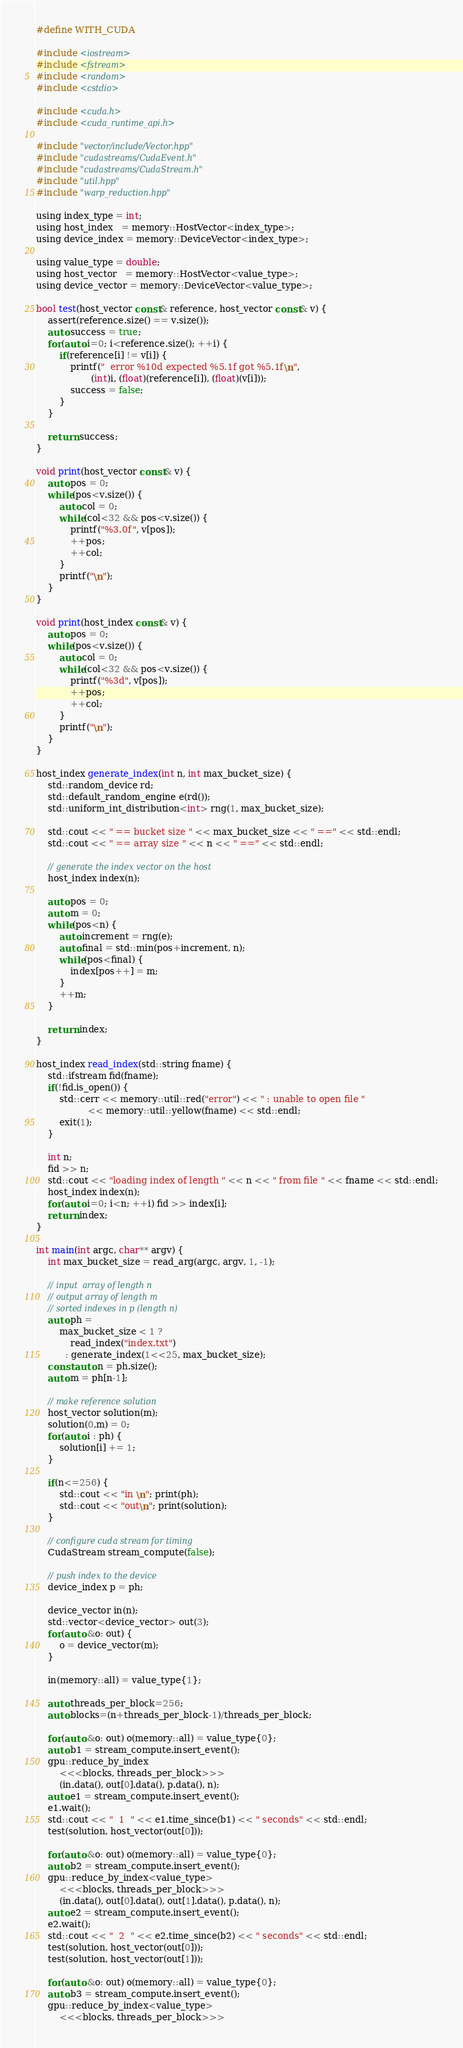<code> <loc_0><loc_0><loc_500><loc_500><_Cuda_>#define WITH_CUDA

#include <iostream>
#include <fstream>
#include <random>
#include <cstdio>

#include <cuda.h>
#include <cuda_runtime_api.h>

#include "vector/include/Vector.hpp"
#include "cudastreams/CudaEvent.h"
#include "cudastreams/CudaStream.h"
#include "util.hpp"
#include "warp_reduction.hpp"

using index_type = int;
using host_index   = memory::HostVector<index_type>;
using device_index = memory::DeviceVector<index_type>;

using value_type = double;
using host_vector   = memory::HostVector<value_type>;
using device_vector = memory::DeviceVector<value_type>;

bool test(host_vector const& reference, host_vector const& v) {
    assert(reference.size() == v.size());
    auto success = true;
    for(auto i=0; i<reference.size(); ++i) {
        if(reference[i] != v[i]) {
            printf("  error %10d expected %5.1f got %5.1f\n",
                   (int)i, (float)(reference[i]), (float)(v[i]));
            success = false;
        }
    }

    return success;
}

void print(host_vector const& v) {
    auto pos = 0;
    while(pos<v.size()) {
        auto col = 0;
        while(col<32 && pos<v.size()) {
            printf("%3.0f", v[pos]);
            ++pos;
            ++col;
        }
        printf("\n");
    }
}

void print(host_index const& v) {
    auto pos = 0;
    while(pos<v.size()) {
        auto col = 0;
        while(col<32 && pos<v.size()) {
            printf("%3d", v[pos]);
            ++pos;
            ++col;
        }
        printf("\n");
    }
}

host_index generate_index(int n, int max_bucket_size) {
    std::random_device rd;
    std::default_random_engine e(rd());
    std::uniform_int_distribution<int> rng(1, max_bucket_size);

    std::cout << " == bucket size " << max_bucket_size << " ==" << std::endl;
    std::cout << " == array size " << n << " ==" << std::endl;

    // generate the index vector on the host
    host_index index(n);

    auto pos = 0;
    auto m = 0;
    while(pos<n) {
        auto increment = rng(e);
        auto final = std::min(pos+increment, n);
        while(pos<final) {
            index[pos++] = m;
        }
        ++m;
    }

    return index;
}

host_index read_index(std::string fname) {
    std::ifstream fid(fname);
    if(!fid.is_open()) {
        std::cerr << memory::util::red("error") << " : unable to open file "
                  << memory::util::yellow(fname) << std::endl;
        exit(1);
    }

    int n;
    fid >> n;
    std::cout << "loading index of length " << n << " from file " << fname << std::endl;
    host_index index(n);
    for(auto i=0; i<n; ++i) fid >> index[i];
    return index;
}

int main(int argc, char** argv) {
    int max_bucket_size = read_arg(argc, argv, 1, -1);

    // input  array of length n
    // output array of length m
    // sorted indexes in p (length n)
    auto ph =
        max_bucket_size < 1 ?
            read_index("index.txt")
          : generate_index(1<<25, max_bucket_size);
    const auto n = ph.size();
    auto m = ph[n-1];

    // make reference solution
    host_vector solution(m);
    solution(0,m) = 0;
    for(auto i : ph) {
        solution[i] += 1;
    }

    if(n<=256) {
        std::cout << "in \n"; print(ph);
        std::cout << "out\n"; print(solution);
    }

    // configure cuda stream for timing
    CudaStream stream_compute(false);

    // push index to the device
    device_index p = ph;

    device_vector in(n);
    std::vector<device_vector> out(3);
    for(auto &o: out) {
        o = device_vector(m);
    }

    in(memory::all) = value_type{1};

    auto threads_per_block=256;
    auto blocks=(n+threads_per_block-1)/threads_per_block;

    for(auto &o: out) o(memory::all) = value_type{0};
    auto b1 = stream_compute.insert_event();
    gpu::reduce_by_index
        <<<blocks, threads_per_block>>>
        (in.data(), out[0].data(), p.data(), n);
    auto e1 = stream_compute.insert_event();
    e1.wait();
    std::cout << "  1  " << e1.time_since(b1) << " seconds" << std::endl;
    test(solution, host_vector(out[0]));

    for(auto &o: out) o(memory::all) = value_type{0};
    auto b2 = stream_compute.insert_event();
    gpu::reduce_by_index<value_type>
        <<<blocks, threads_per_block>>>
        (in.data(), out[0].data(), out[1].data(), p.data(), n);
    auto e2 = stream_compute.insert_event();
    e2.wait();
    std::cout << "  2  " << e2.time_since(b2) << " seconds" << std::endl;
    test(solution, host_vector(out[0]));
    test(solution, host_vector(out[1]));

    for(auto &o: out) o(memory::all) = value_type{0};
    auto b3 = stream_compute.insert_event();
    gpu::reduce_by_index<value_type>
        <<<blocks, threads_per_block>>></code> 